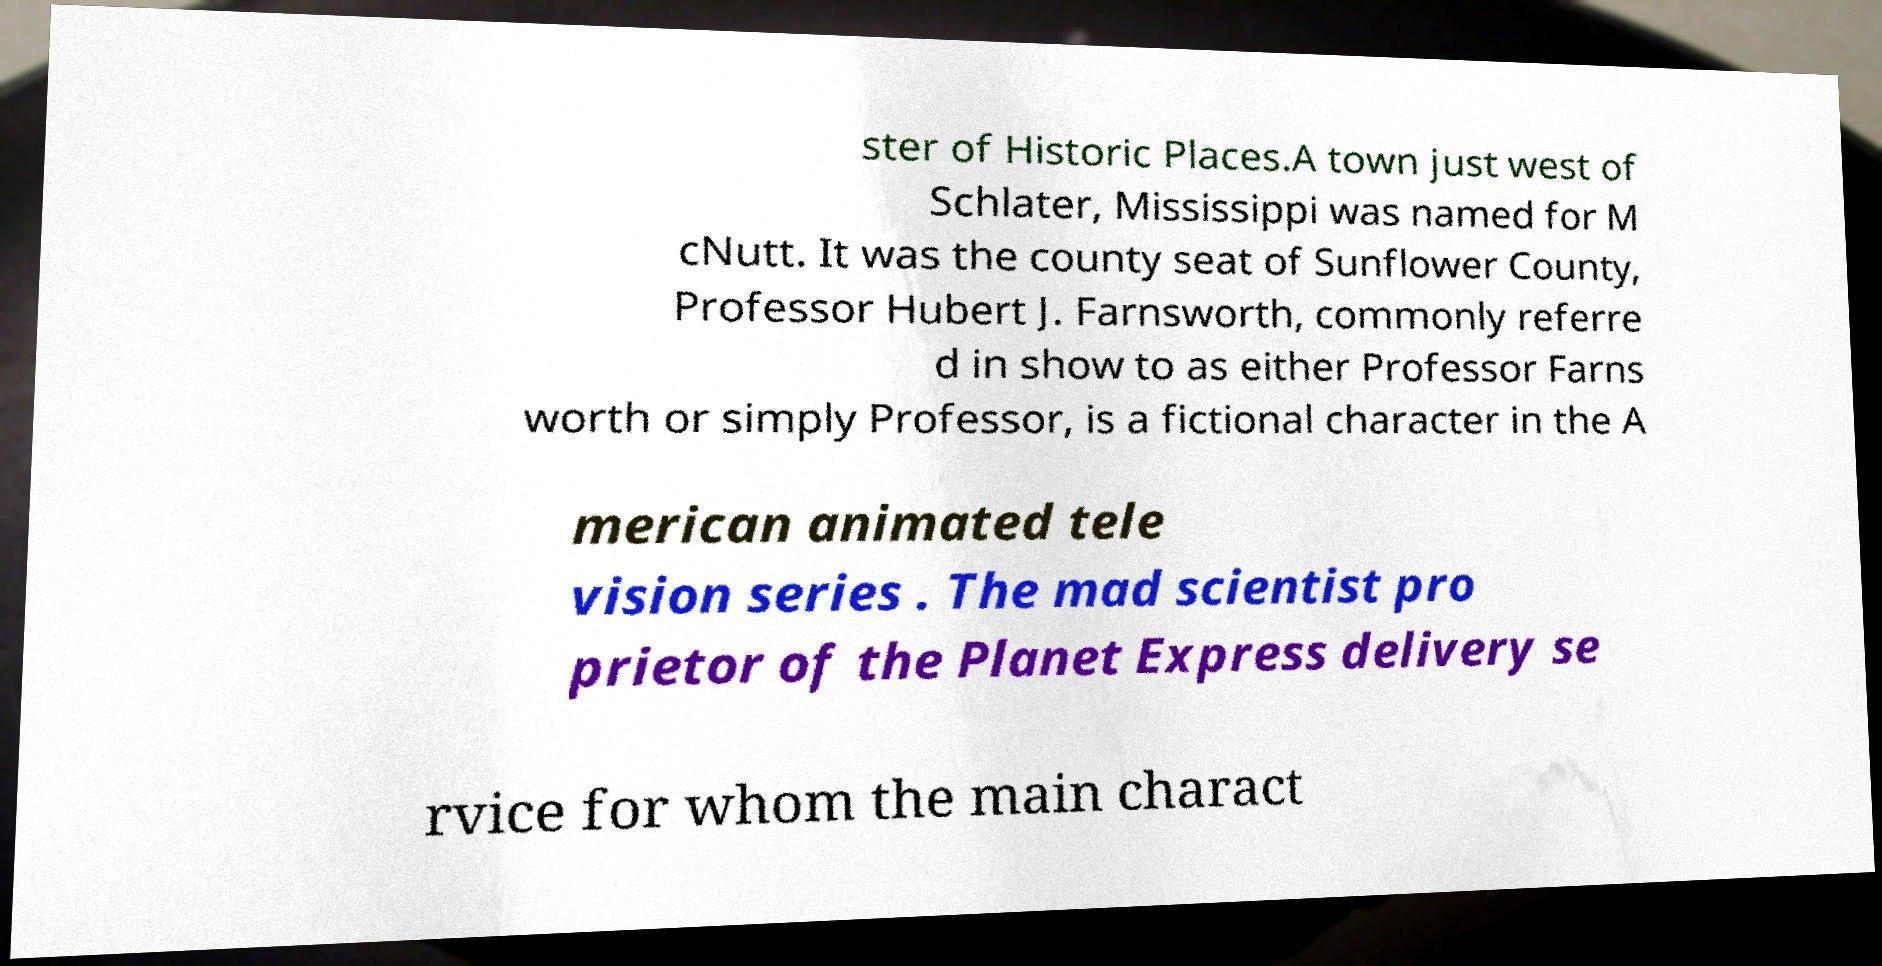Can you read and provide the text displayed in the image?This photo seems to have some interesting text. Can you extract and type it out for me? ster of Historic Places.A town just west of Schlater, Mississippi was named for M cNutt. It was the county seat of Sunflower County, Professor Hubert J. Farnsworth, commonly referre d in show to as either Professor Farns worth or simply Professor, is a fictional character in the A merican animated tele vision series . The mad scientist pro prietor of the Planet Express delivery se rvice for whom the main charact 